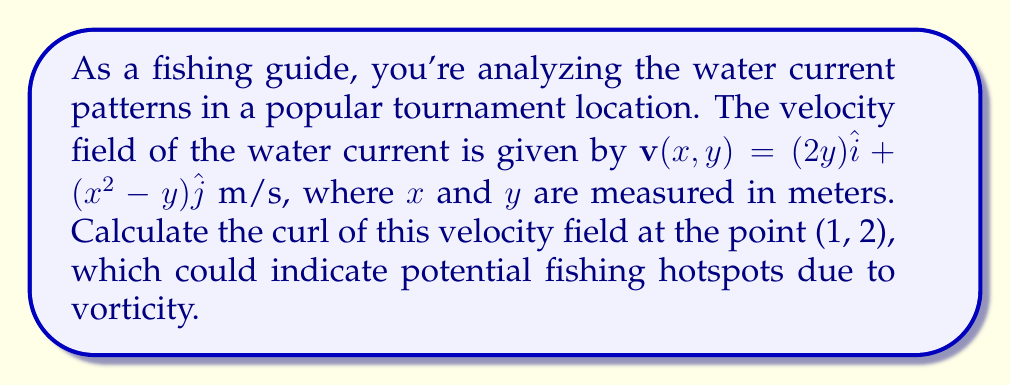Give your solution to this math problem. To solve this problem, we need to calculate the curl of the given vector field. The curl in two dimensions is defined as:

$$\text{curl }\mathbf{v} = \nabla \times \mathbf{v} = \left(\frac{\partial v_y}{\partial x} - \frac{\partial v_x}{\partial y}\right)\hat{k}$$

Where:
$v_x = 2y$ and $v_y = x^2-y$

Step 1: Calculate $\frac{\partial v_y}{\partial x}$
$$\frac{\partial v_y}{\partial x} = \frac{\partial}{\partial x}(x^2-y) = 2x$$

Step 2: Calculate $\frac{\partial v_x}{\partial y}$
$$\frac{\partial v_x}{\partial y} = \frac{\partial}{\partial y}(2y) = 2$$

Step 3: Substitute into the curl formula
$$\text{curl }\mathbf{v} = (2x - 2)\hat{k}$$

Step 4: Evaluate at the point (1, 2)
$$\text{curl }\mathbf{v}(1,2) = (2(1) - 2)\hat{k} = 0\hat{k}$$

The curl at the point (1, 2) is zero, indicating no rotational flow at this specific location.
Answer: $0\hat{k}$ m/s² 